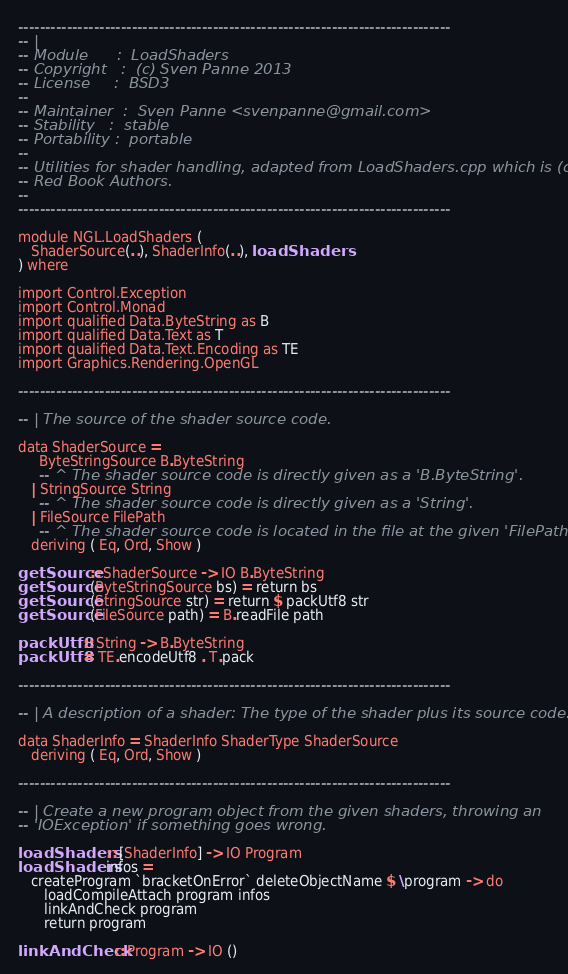<code> <loc_0><loc_0><loc_500><loc_500><_Haskell_>--------------------------------------------------------------------------------
-- |
-- Module      :  LoadShaders
-- Copyright   :  (c) Sven Panne 2013
-- License     :  BSD3
--
-- Maintainer  :  Sven Panne <svenpanne@gmail.com>
-- Stability   :  stable
-- Portability :  portable
--
-- Utilities for shader handling, adapted from LoadShaders.cpp which is (c) The
-- Red Book Authors.
--
--------------------------------------------------------------------------------

module NGL.LoadShaders (
   ShaderSource(..), ShaderInfo(..), loadShaders
) where

import Control.Exception
import Control.Monad
import qualified Data.ByteString as B
import qualified Data.Text as T
import qualified Data.Text.Encoding as TE
import Graphics.Rendering.OpenGL

--------------------------------------------------------------------------------

-- | The source of the shader source code.

data ShaderSource =
     ByteStringSource B.ByteString
     -- ^ The shader source code is directly given as a 'B.ByteString'.
   | StringSource String
     -- ^ The shader source code is directly given as a 'String'.
   | FileSource FilePath
     -- ^ The shader source code is located in the file at the given 'FilePath'.
   deriving ( Eq, Ord, Show )

getSource :: ShaderSource -> IO B.ByteString
getSource (ByteStringSource bs) = return bs
getSource (StringSource str) = return $ packUtf8 str
getSource (FileSource path) = B.readFile path

packUtf8 :: String -> B.ByteString
packUtf8 = TE.encodeUtf8 . T.pack

--------------------------------------------------------------------------------

-- | A description of a shader: The type of the shader plus its source code.

data ShaderInfo = ShaderInfo ShaderType ShaderSource
   deriving ( Eq, Ord, Show )

--------------------------------------------------------------------------------

-- | Create a new program object from the given shaders, throwing an
-- 'IOException' if something goes wrong.

loadShaders :: [ShaderInfo] -> IO Program
loadShaders infos =
   createProgram `bracketOnError` deleteObjectName $ \program -> do
      loadCompileAttach program infos
      linkAndCheck program
      return program

linkAndCheck :: Program -> IO ()</code> 